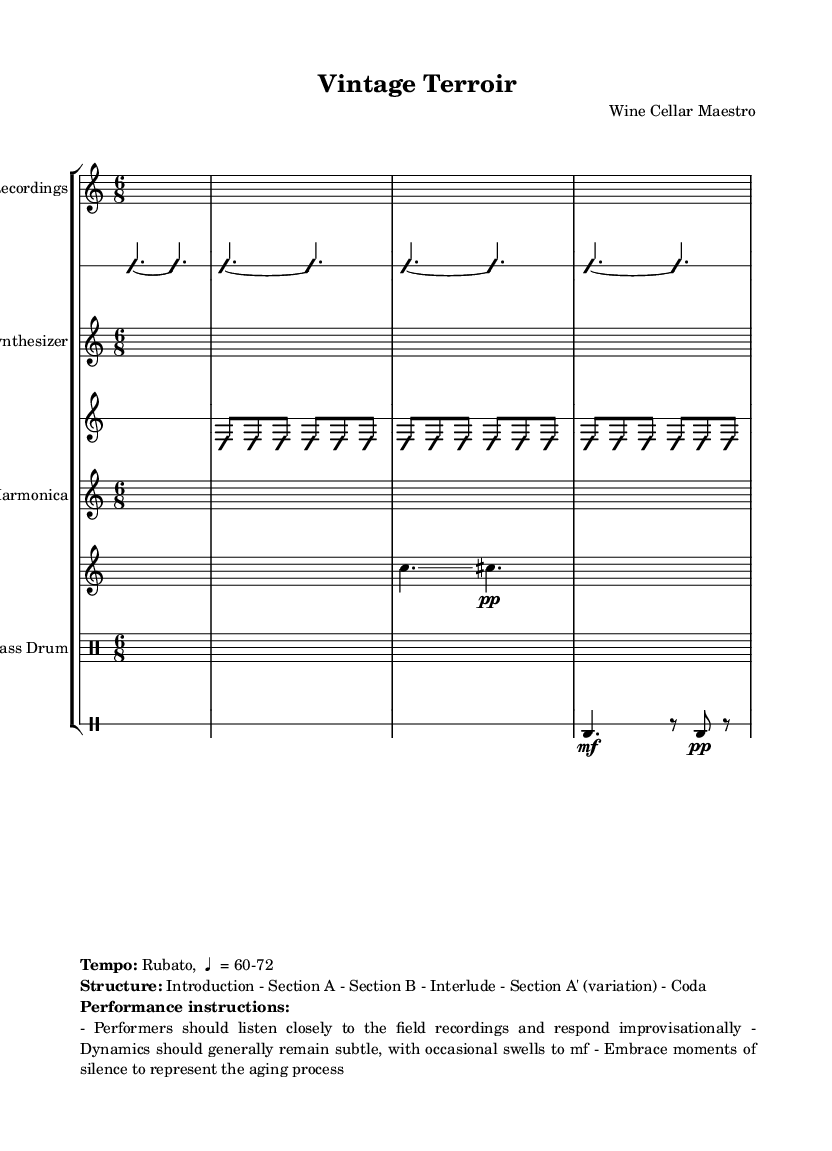What is the time signature of this piece? The time signature is indicated at the beginning of each staff with the fraction format. In this case, it shows "6/8," meaning there are six eighth notes in each measure.
Answer: 6/8 What tempo is indicated for the performance? The tempo is detailed in the markup section at the bottom of the score. It specifies "Rubato, ♩ = 60-72," indicating a flexible tempo around 60 to 72 beats per minute.
Answer: Rubato, ♩ = 60-72 How many sections are in the structure of the composition? The structure is outlined in the marked instructions at the bottom. It lists "Introduction - Section A - Section B - Interlude - Section A' (variation) - Coda," totaling six distinct sections.
Answer: 6 What kind of instrument is used for field recordings? The field recordings are indicated by the specific staff labeled "Field Recordings," suggestive of natural sounds, which in this context refers to recorded sounds from grape harvests and winemaking techniques.
Answer: Field Recordings What dynamics should performers generally aim for? Performance instructions in the markup section mention that "Dynamics should generally remain subtle," pointing towards a soft performance style with moments of increased volume.
Answer: Subtle What does the 'improvisationOn' directive imply for performers? The directive "improvisationOn" appears in multiple instrument parts, signaling that performers are encouraged to create spontaneous variations based on the given framework without rigid adherence to the written notes.
Answer: Spontaneity 